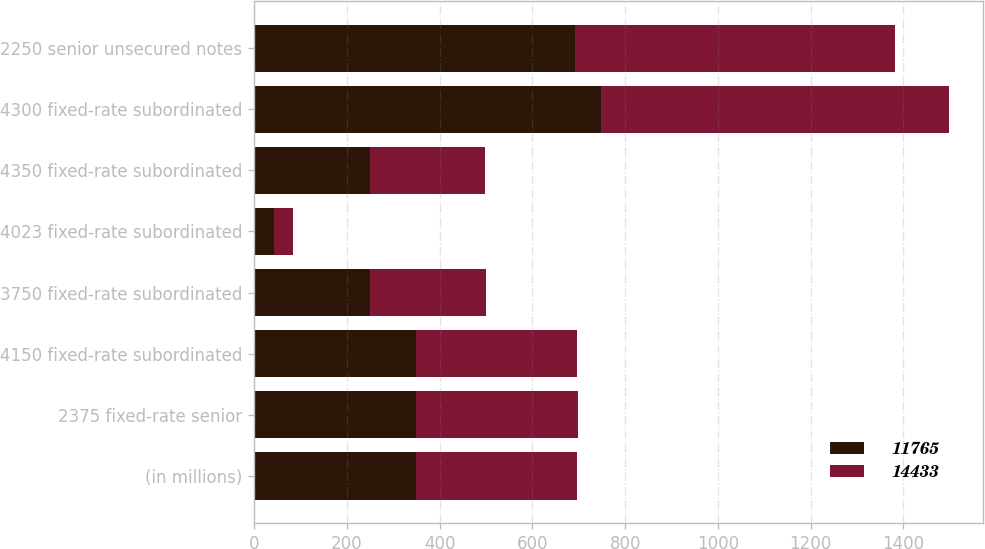Convert chart to OTSL. <chart><loc_0><loc_0><loc_500><loc_500><stacked_bar_chart><ecel><fcel>(in millions)<fcel>2375 fixed-rate senior<fcel>4150 fixed-rate subordinated<fcel>3750 fixed-rate subordinated<fcel>4023 fixed-rate subordinated<fcel>4350 fixed-rate subordinated<fcel>4300 fixed-rate subordinated<fcel>2250 senior unsecured notes<nl><fcel>11765<fcel>348<fcel>349<fcel>348<fcel>250<fcel>42<fcel>249<fcel>749<fcel>691<nl><fcel>14433<fcel>348<fcel>349<fcel>348<fcel>250<fcel>42<fcel>249<fcel>749<fcel>692<nl></chart> 